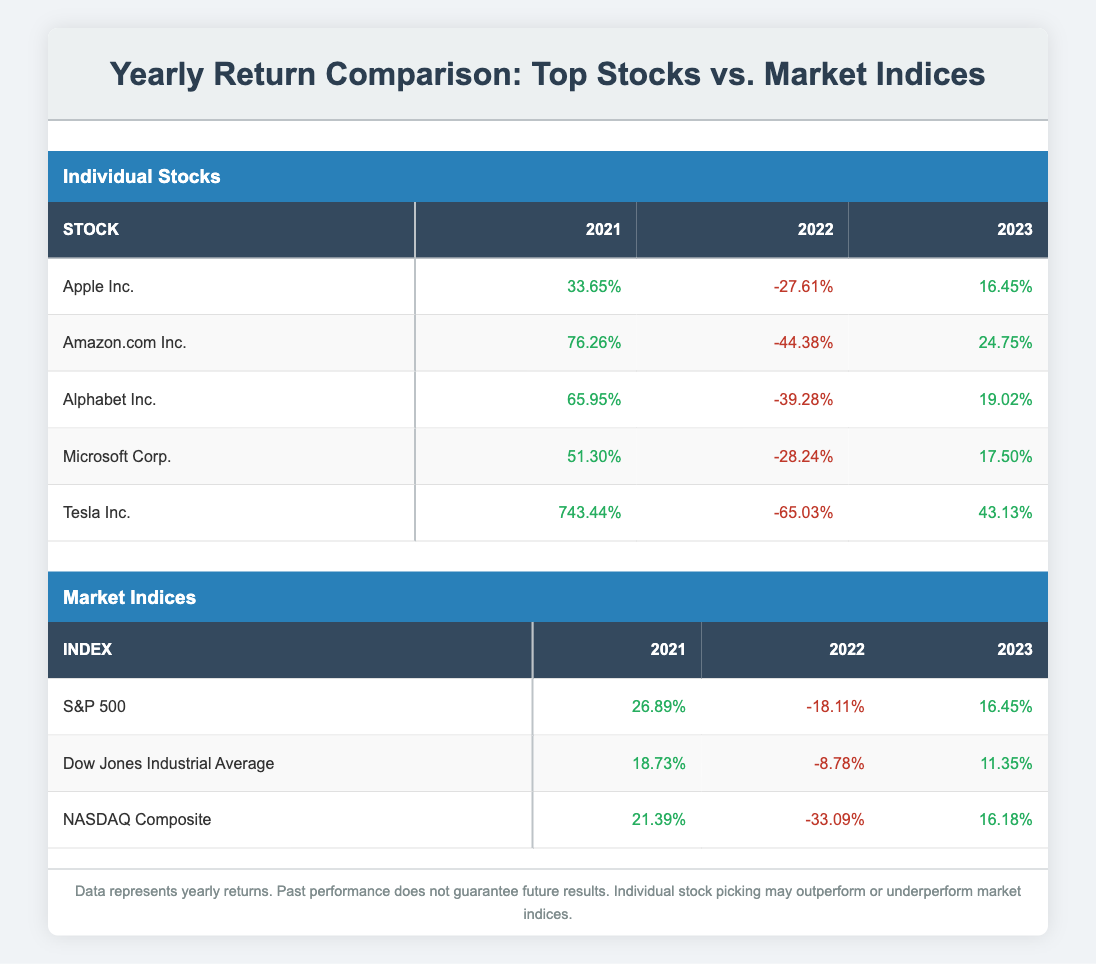What was Tesla Inc.'s return in 2021? Referring to the table, Tesla Inc. had a return of 743.44% in the year 2021.
Answer: 743.44% Which market index had the highest return in 2022? By comparing the returns for 2022 across the market indices, the S&P 500 had the highest return of -18.11% (less negative) compared to the other indices, Dow Jones Industrial Average and NASDAQ Composite.
Answer: S&P 500 What is the average return of Apple Inc. over the three years? To find the average return, add the returns for Apple Inc. over the years: (33.65 + (-27.61) + 16.45) = 22.49. Then divide by the number of years (3): 22.49 / 3 = 7.50.
Answer: 7.50% Was Amazon.com Inc.'s return in 2023 higher or lower than 10%? Amazon.com Inc. had a return of 24.75% in 2023, which is higher than 10%.
Answer: Higher Which stock had the lowest return in 2022? The lowest return in 2022 can be found by checking each stock's return. Amazon.com Inc. had the lowest return of -44.38%.
Answer: Amazon.com Inc 